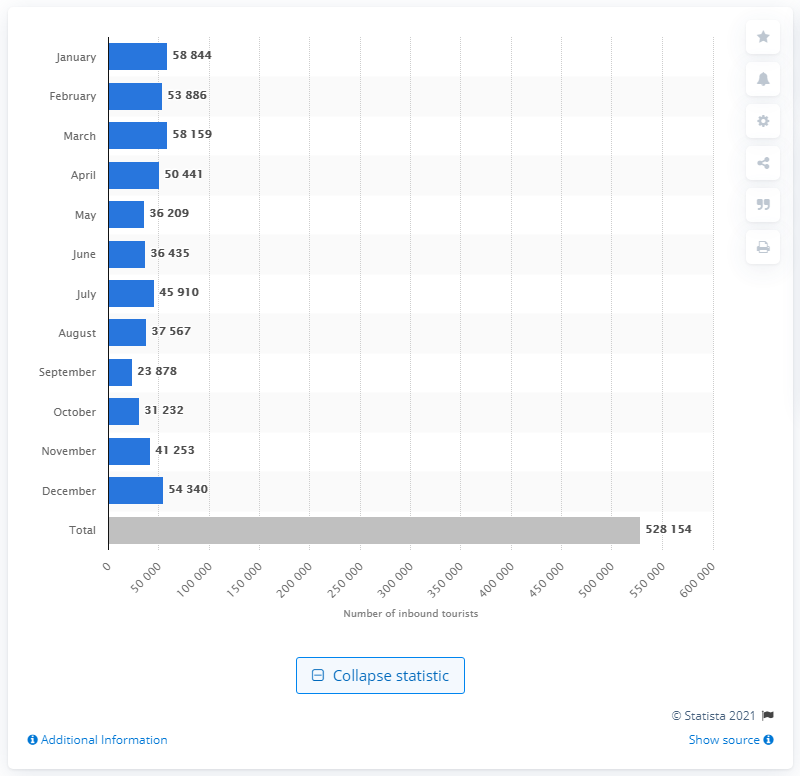Outline some significant characteristics in this image. According to the data, January was the month that saw the highest number of inbound tourists arriving in Sint Maarten by air. 